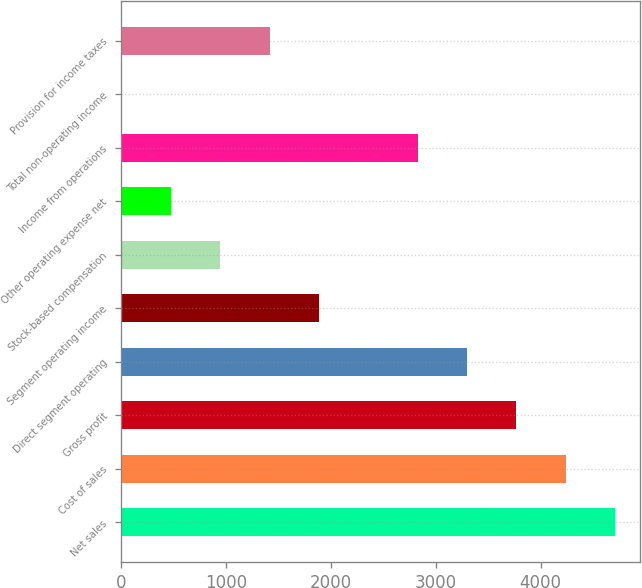<chart> <loc_0><loc_0><loc_500><loc_500><bar_chart><fcel>Net sales<fcel>Cost of sales<fcel>Gross profit<fcel>Direct segment operating<fcel>Segment operating income<fcel>Stock-based compensation<fcel>Other operating expense net<fcel>Income from operations<fcel>Total non-operating income<fcel>Provision for income taxes<nl><fcel>4711<fcel>4240.3<fcel>3769.6<fcel>3298.9<fcel>1886.8<fcel>945.4<fcel>474.7<fcel>2828.2<fcel>4<fcel>1416.1<nl></chart> 